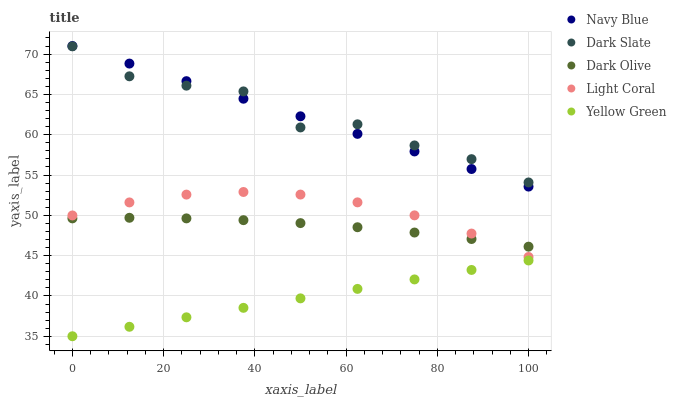Does Yellow Green have the minimum area under the curve?
Answer yes or no. Yes. Does Dark Slate have the maximum area under the curve?
Answer yes or no. Yes. Does Navy Blue have the minimum area under the curve?
Answer yes or no. No. Does Navy Blue have the maximum area under the curve?
Answer yes or no. No. Is Navy Blue the smoothest?
Answer yes or no. Yes. Is Dark Slate the roughest?
Answer yes or no. Yes. Is Dark Olive the smoothest?
Answer yes or no. No. Is Dark Olive the roughest?
Answer yes or no. No. Does Yellow Green have the lowest value?
Answer yes or no. Yes. Does Navy Blue have the lowest value?
Answer yes or no. No. Does Navy Blue have the highest value?
Answer yes or no. Yes. Does Dark Olive have the highest value?
Answer yes or no. No. Is Yellow Green less than Dark Olive?
Answer yes or no. Yes. Is Dark Slate greater than Light Coral?
Answer yes or no. Yes. Does Navy Blue intersect Dark Slate?
Answer yes or no. Yes. Is Navy Blue less than Dark Slate?
Answer yes or no. No. Is Navy Blue greater than Dark Slate?
Answer yes or no. No. Does Yellow Green intersect Dark Olive?
Answer yes or no. No. 